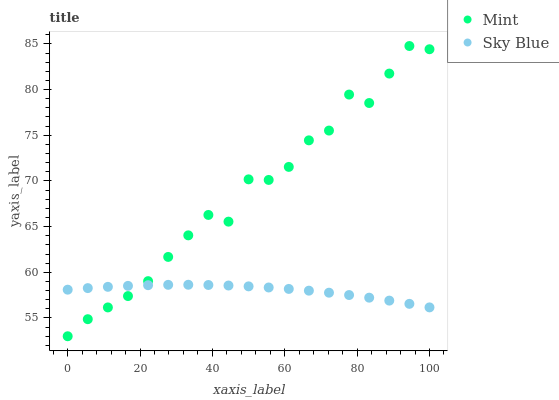Does Sky Blue have the minimum area under the curve?
Answer yes or no. Yes. Does Mint have the maximum area under the curve?
Answer yes or no. Yes. Does Mint have the minimum area under the curve?
Answer yes or no. No. Is Sky Blue the smoothest?
Answer yes or no. Yes. Is Mint the roughest?
Answer yes or no. Yes. Is Mint the smoothest?
Answer yes or no. No. Does Mint have the lowest value?
Answer yes or no. Yes. Does Mint have the highest value?
Answer yes or no. Yes. Does Sky Blue intersect Mint?
Answer yes or no. Yes. Is Sky Blue less than Mint?
Answer yes or no. No. Is Sky Blue greater than Mint?
Answer yes or no. No. 